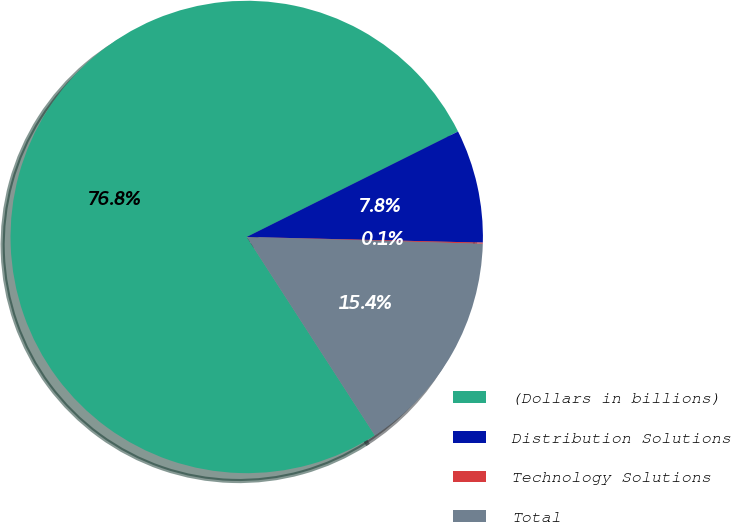Convert chart. <chart><loc_0><loc_0><loc_500><loc_500><pie_chart><fcel>(Dollars in billions)<fcel>Distribution Solutions<fcel>Technology Solutions<fcel>Total<nl><fcel>76.76%<fcel>7.75%<fcel>0.08%<fcel>15.41%<nl></chart> 